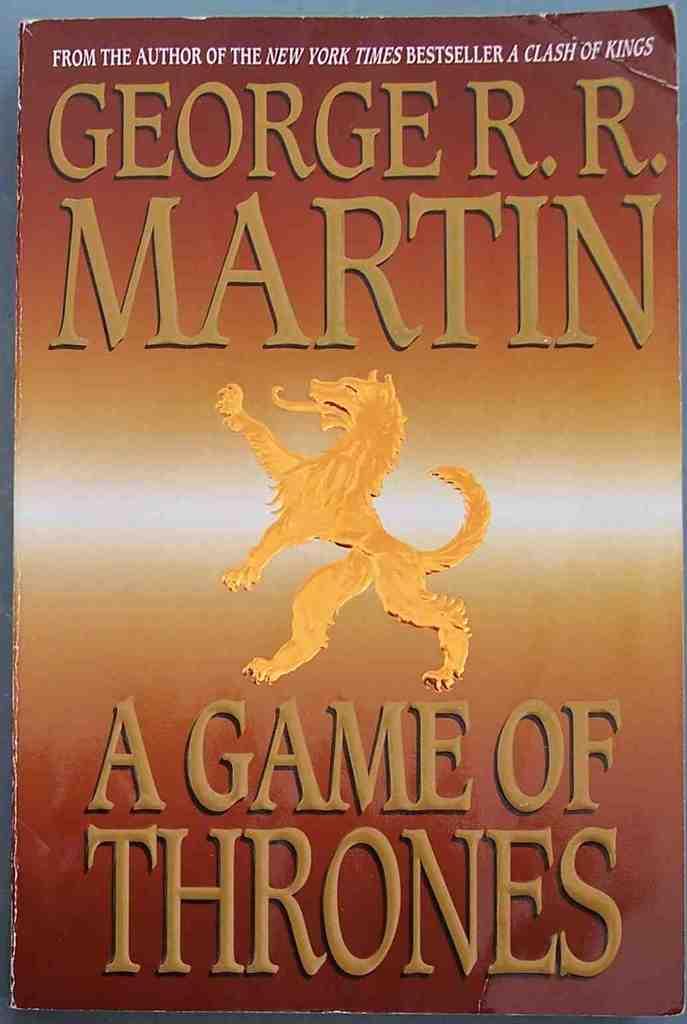Who is the author of this fantastic series?
Make the answer very short. George r.r. martin. What is the title of the book?
Give a very brief answer. A game of thrones. 